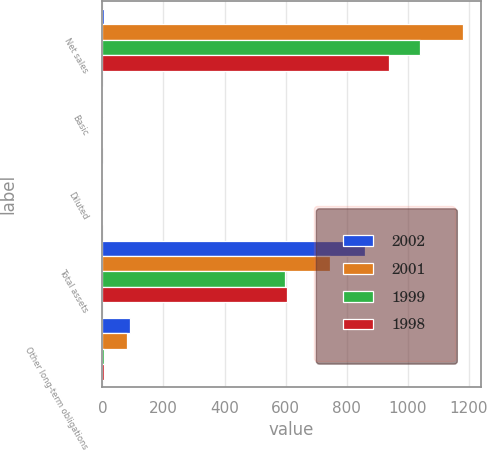Convert chart. <chart><loc_0><loc_0><loc_500><loc_500><stacked_bar_chart><ecel><fcel>Net sales<fcel>Basic<fcel>Diluted<fcel>Total assets<fcel>Other long-term obligations<nl><fcel>2002<fcel>5.5<fcel>1.33<fcel>1.31<fcel>858.9<fcel>91.8<nl><fcel>2001<fcel>1178.6<fcel>0.77<fcel>0.77<fcel>745<fcel>79.3<nl><fcel>1999<fcel>1040.6<fcel>0.91<fcel>0.91<fcel>597.4<fcel>5.5<nl><fcel>1998<fcel>938.9<fcel>0.77<fcel>0.77<fcel>605.6<fcel>4.2<nl></chart> 